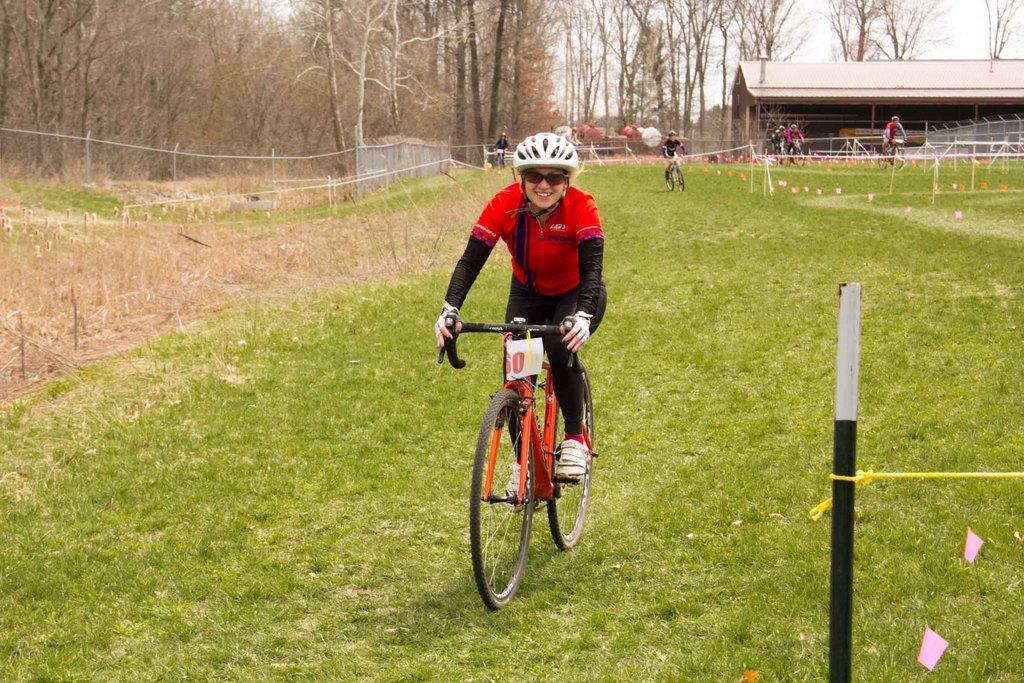Describe this image in one or two sentences. In this image there are a few people riding bicycles. In the foreground there is a woman riding bicycle. She is wearing spectacles and helmet. There is grass on the ground. To the left there is a fencing. To the right there is a shed. In the background there are trees. At the top there is the sky. 